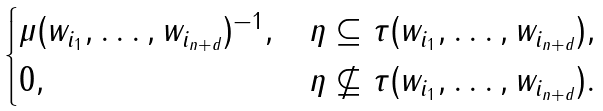Convert formula to latex. <formula><loc_0><loc_0><loc_500><loc_500>\begin{cases} \mu ( w _ { i _ { 1 } } , \dots , w _ { i _ { n + d } } ) ^ { - 1 } , & \eta \subseteq \tau ( w _ { i _ { 1 } } , \dots , w _ { i _ { n + d } } ) , \\ 0 , & \eta \not \subseteq \tau ( w _ { i _ { 1 } } , \dots , w _ { i _ { n + d } } ) . \end{cases}</formula> 